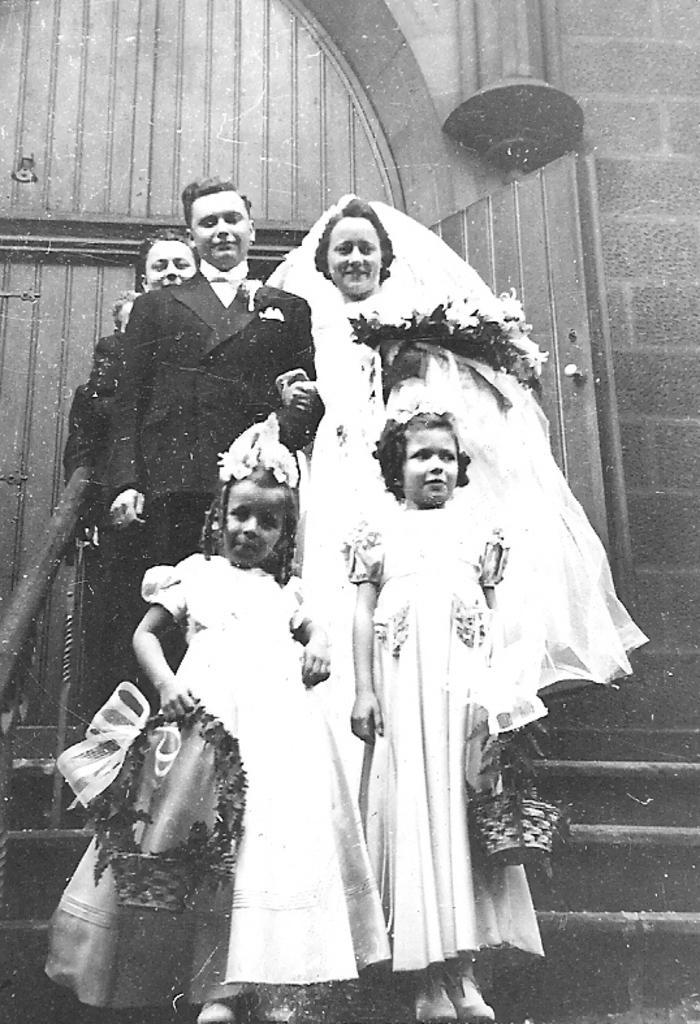In one or two sentences, can you explain what this image depicts? In this image there is a bride and groom along with some people standing on the stairs, behind them there is a building. 